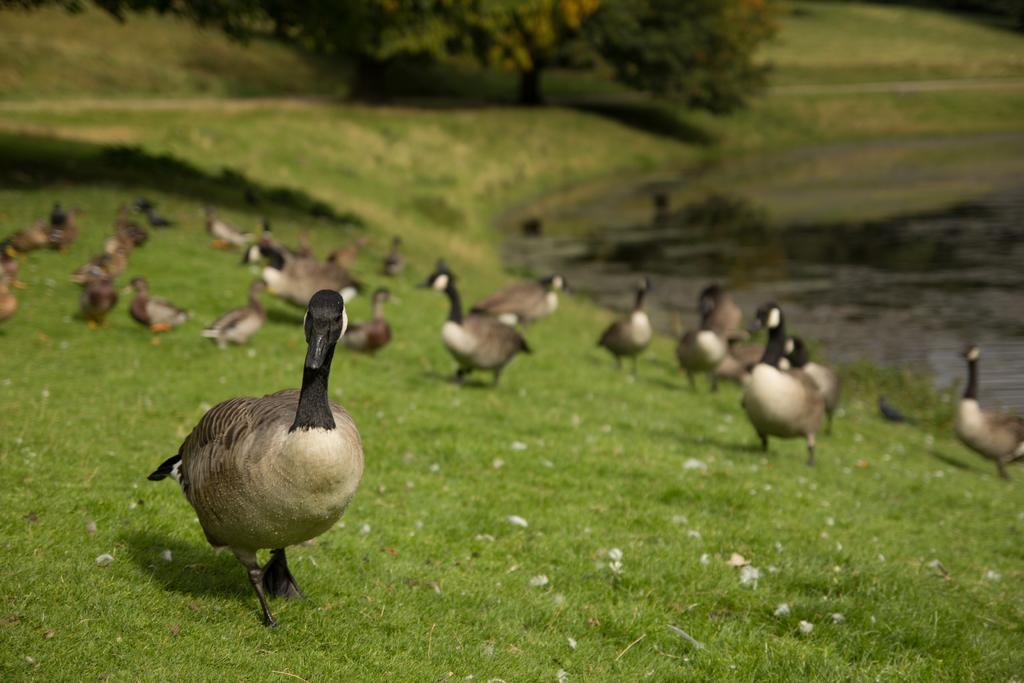Could you give a brief overview of what you see in this image? In the center of the image we can see ducks on the grass. In the background we can see trees, water and grass. 